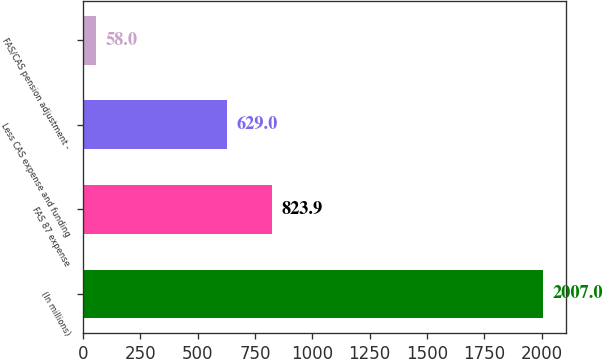Convert chart to OTSL. <chart><loc_0><loc_0><loc_500><loc_500><bar_chart><fcel>(In millions)<fcel>FAS 87 expense<fcel>Less CAS expense and funding<fcel>FAS/CAS pension adjustment -<nl><fcel>2007<fcel>823.9<fcel>629<fcel>58<nl></chart> 